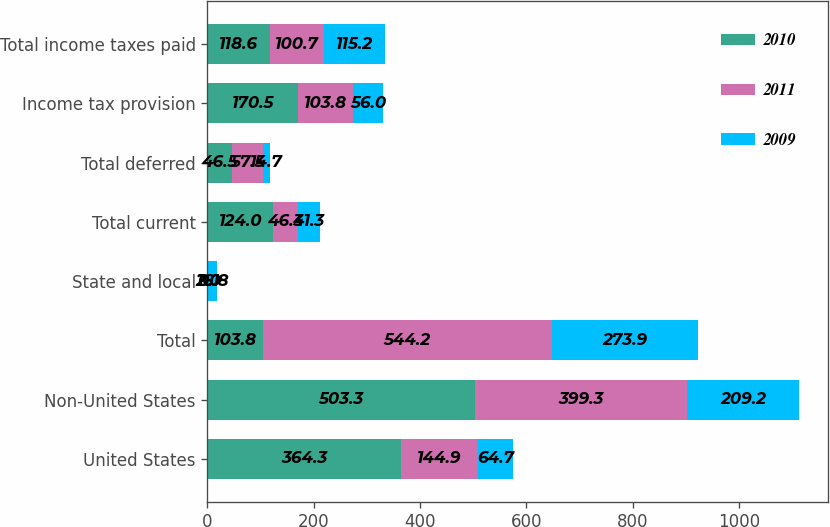<chart> <loc_0><loc_0><loc_500><loc_500><stacked_bar_chart><ecel><fcel>United States<fcel>Non-United States<fcel>Total<fcel>State and local<fcel>Total current<fcel>Total deferred<fcel>Income tax provision<fcel>Total income taxes paid<nl><fcel>2010<fcel>364.3<fcel>503.3<fcel>103.8<fcel>2<fcel>124<fcel>46.5<fcel>170.5<fcel>118.6<nl><fcel>2011<fcel>144.9<fcel>399.3<fcel>544.2<fcel>0.1<fcel>46.3<fcel>57.5<fcel>103.8<fcel>100.7<nl><fcel>2009<fcel>64.7<fcel>209.2<fcel>273.9<fcel>16.8<fcel>41.3<fcel>14.7<fcel>56<fcel>115.2<nl></chart> 